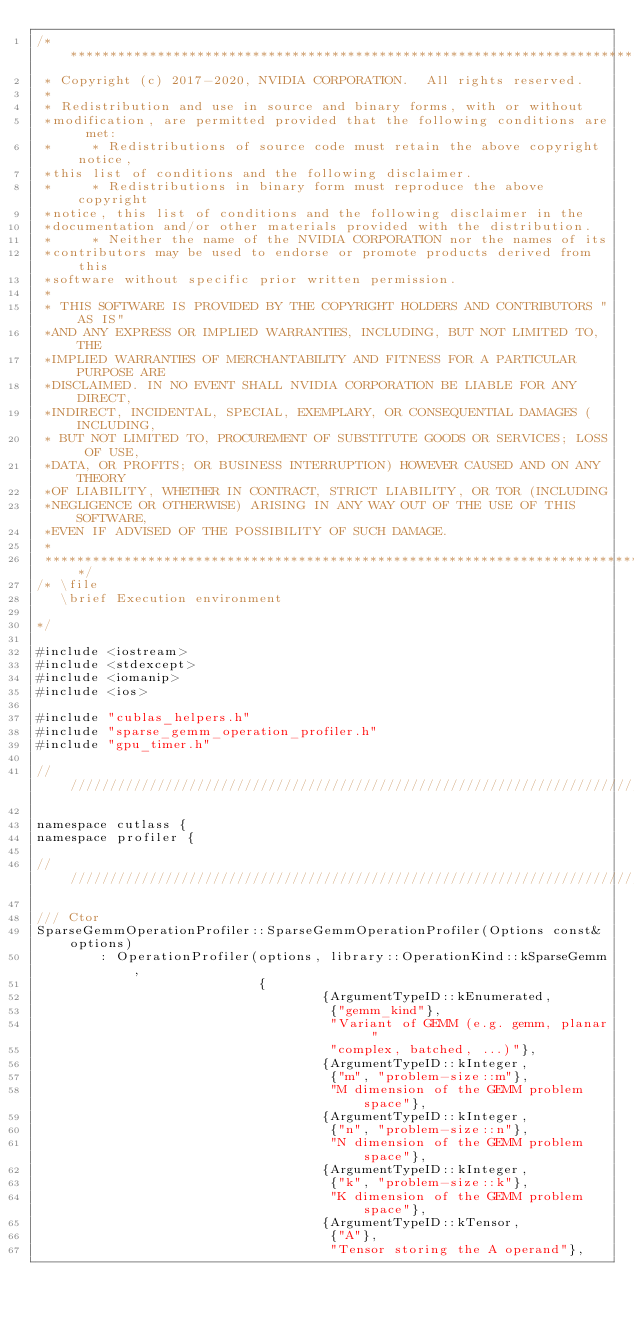<code> <loc_0><loc_0><loc_500><loc_500><_Cuda_>/***************************************************************************************************
 * Copyright (c) 2017-2020, NVIDIA CORPORATION.  All rights reserved.
 *
 * Redistribution and use in source and binary forms, with or without
 *modification, are permitted provided that the following conditions are met:
 *     * Redistributions of source code must retain the above copyright notice,
 *this list of conditions and the following disclaimer.
 *     * Redistributions in binary form must reproduce the above copyright
 *notice, this list of conditions and the following disclaimer in the
 *documentation and/or other materials provided with the distribution.
 *     * Neither the name of the NVIDIA CORPORATION nor the names of its
 *contributors may be used to endorse or promote products derived from this
 *software without specific prior written permission.
 *
 * THIS SOFTWARE IS PROVIDED BY THE COPYRIGHT HOLDERS AND CONTRIBUTORS "AS IS"
 *AND ANY EXPRESS OR IMPLIED WARRANTIES, INCLUDING, BUT NOT LIMITED TO, THE
 *IMPLIED WARRANTIES OF MERCHANTABILITY AND FITNESS FOR A PARTICULAR PURPOSE ARE
 *DISCLAIMED. IN NO EVENT SHALL NVIDIA CORPORATION BE LIABLE FOR ANY DIRECT,
 *INDIRECT, INCIDENTAL, SPECIAL, EXEMPLARY, OR CONSEQUENTIAL DAMAGES (INCLUDING,
 * BUT NOT LIMITED TO, PROCUREMENT OF SUBSTITUTE GOODS OR SERVICES; LOSS OF USE,
 *DATA, OR PROFITS; OR BUSINESS INTERRUPTION) HOWEVER CAUSED AND ON ANY THEORY
 *OF LIABILITY, WHETHER IN CONTRACT, STRICT LIABILITY, OR TOR (INCLUDING
 *NEGLIGENCE OR OTHERWISE) ARISING IN ANY WAY OUT OF THE USE OF THIS SOFTWARE,
 *EVEN IF ADVISED OF THE POSSIBILITY OF SUCH DAMAGE.
 *
 **************************************************************************************************/
/* \file
   \brief Execution environment

*/

#include <iostream>
#include <stdexcept>
#include <iomanip>
#include <ios>

#include "cublas_helpers.h"
#include "sparse_gemm_operation_profiler.h"
#include "gpu_timer.h"

/////////////////////////////////////////////////////////////////////////////////////////////////

namespace cutlass {
namespace profiler {

/////////////////////////////////////////////////////////////////////////////////////////////////

/// Ctor
SparseGemmOperationProfiler::SparseGemmOperationProfiler(Options const& options)
        : OperationProfiler(options, library::OperationKind::kSparseGemm,
                            {
                                    {ArgumentTypeID::kEnumerated,
                                     {"gemm_kind"},
                                     "Variant of GEMM (e.g. gemm, planar "
                                     "complex, batched, ...)"},
                                    {ArgumentTypeID::kInteger,
                                     {"m", "problem-size::m"},
                                     "M dimension of the GEMM problem space"},
                                    {ArgumentTypeID::kInteger,
                                     {"n", "problem-size::n"},
                                     "N dimension of the GEMM problem space"},
                                    {ArgumentTypeID::kInteger,
                                     {"k", "problem-size::k"},
                                     "K dimension of the GEMM problem space"},
                                    {ArgumentTypeID::kTensor,
                                     {"A"},
                                     "Tensor storing the A operand"},</code> 